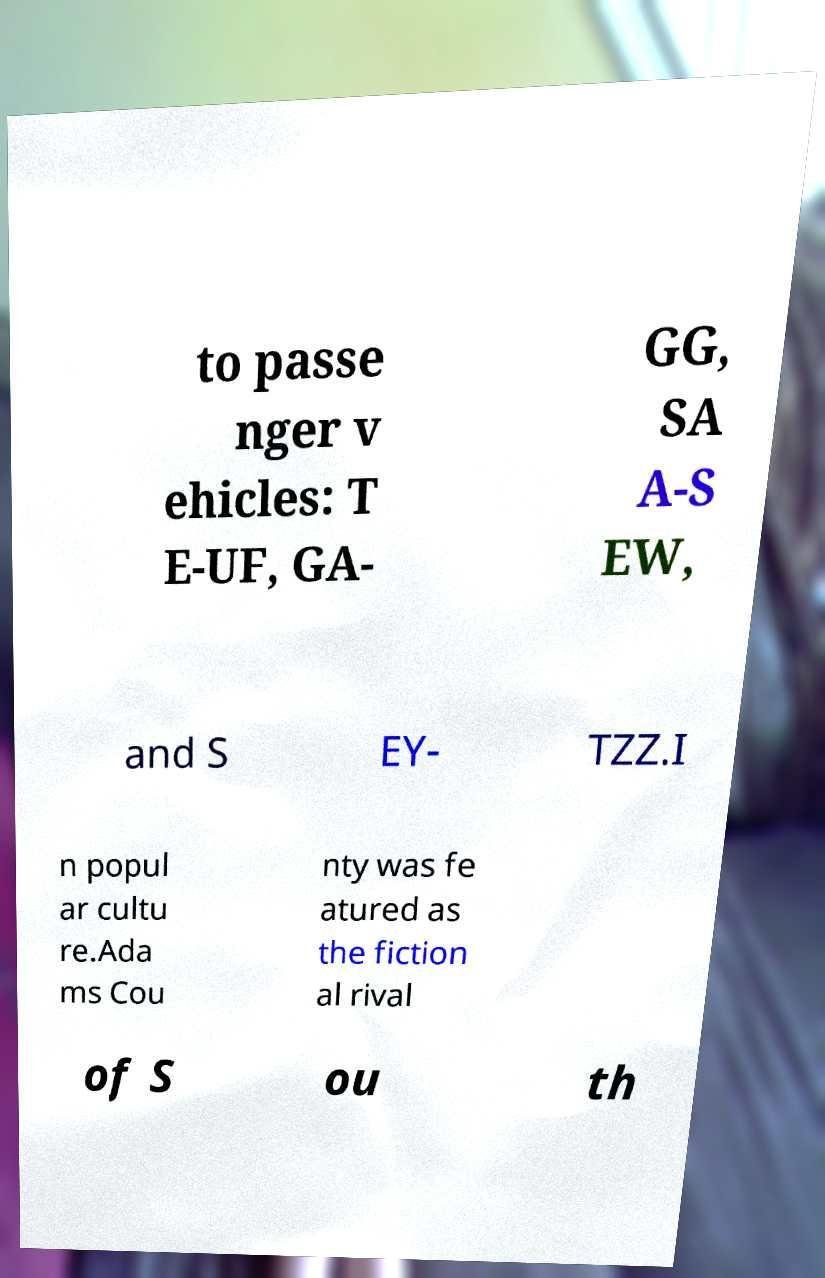Could you assist in decoding the text presented in this image and type it out clearly? to passe nger v ehicles: T E-UF, GA- GG, SA A-S EW, and S EY- TZZ.I n popul ar cultu re.Ada ms Cou nty was fe atured as the fiction al rival of S ou th 